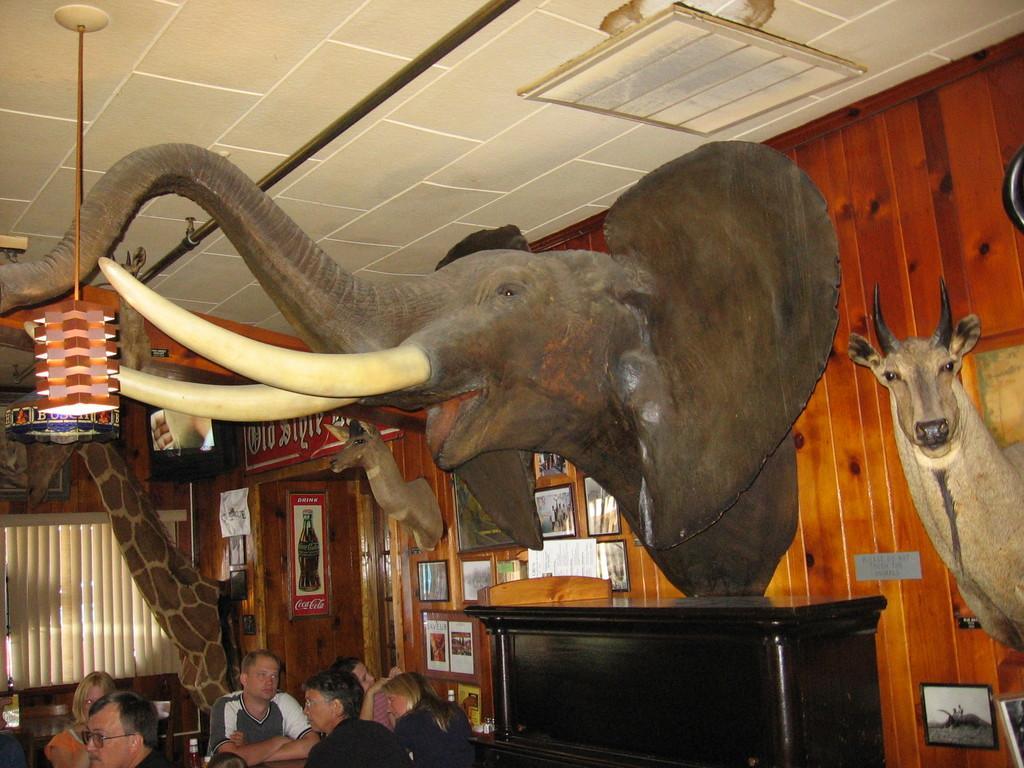In one or two sentences, can you explain what this image depicts? In this image, we can see animal statues, photo frames are on the wall. At the bottom of the image, we can see a group of people are sitting. Here we can see window shades, light, television and few things. Top of the image, we can see the ceiling and rod. 